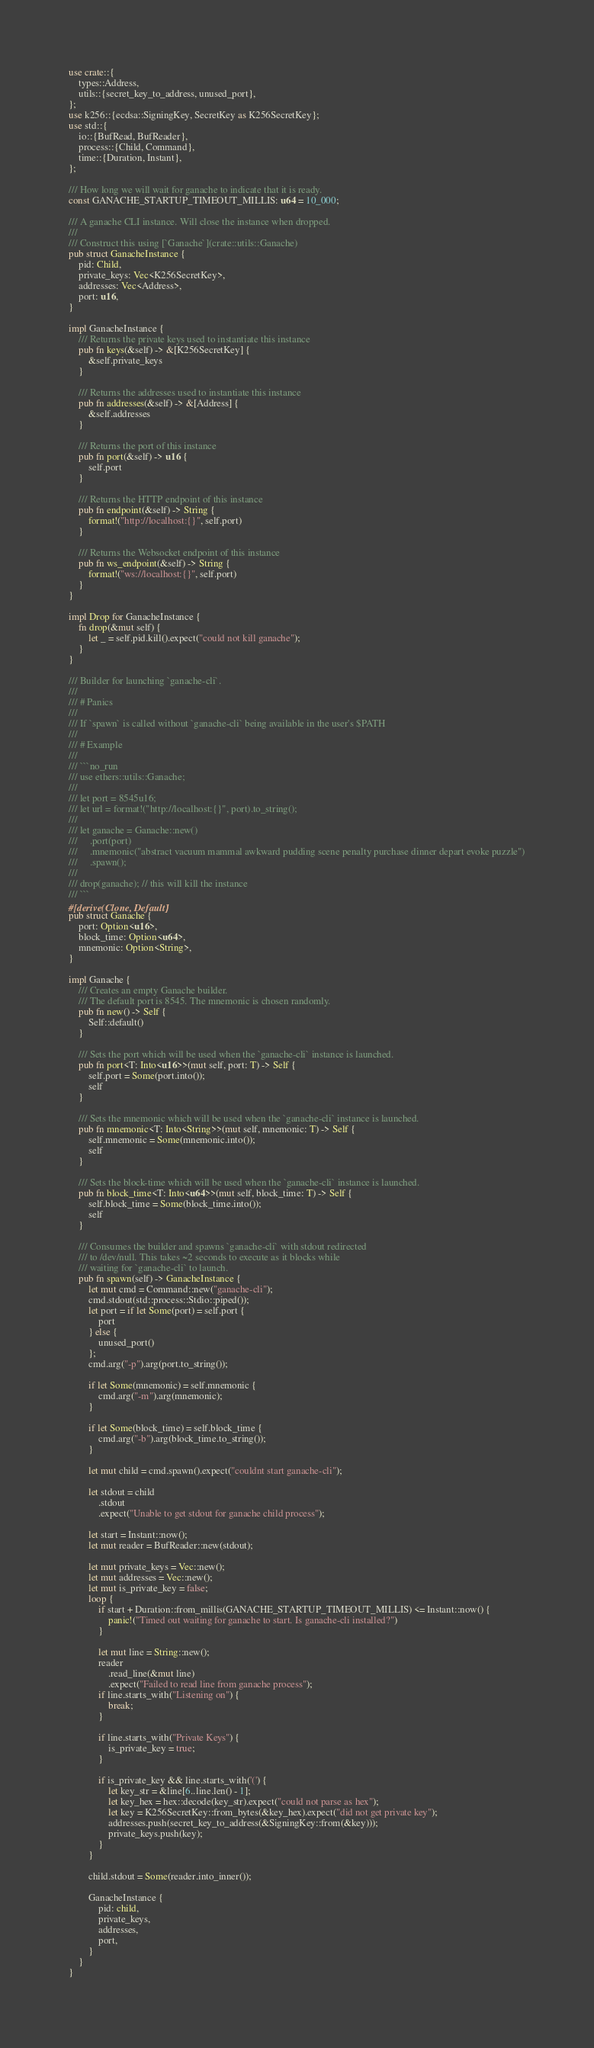Convert code to text. <code><loc_0><loc_0><loc_500><loc_500><_Rust_>use crate::{
    types::Address,
    utils::{secret_key_to_address, unused_port},
};
use k256::{ecdsa::SigningKey, SecretKey as K256SecretKey};
use std::{
    io::{BufRead, BufReader},
    process::{Child, Command},
    time::{Duration, Instant},
};

/// How long we will wait for ganache to indicate that it is ready.
const GANACHE_STARTUP_TIMEOUT_MILLIS: u64 = 10_000;

/// A ganache CLI instance. Will close the instance when dropped.
///
/// Construct this using [`Ganache`](crate::utils::Ganache)
pub struct GanacheInstance {
    pid: Child,
    private_keys: Vec<K256SecretKey>,
    addresses: Vec<Address>,
    port: u16,
}

impl GanacheInstance {
    /// Returns the private keys used to instantiate this instance
    pub fn keys(&self) -> &[K256SecretKey] {
        &self.private_keys
    }

    /// Returns the addresses used to instantiate this instance
    pub fn addresses(&self) -> &[Address] {
        &self.addresses
    }

    /// Returns the port of this instance
    pub fn port(&self) -> u16 {
        self.port
    }

    /// Returns the HTTP endpoint of this instance
    pub fn endpoint(&self) -> String {
        format!("http://localhost:{}", self.port)
    }

    /// Returns the Websocket endpoint of this instance
    pub fn ws_endpoint(&self) -> String {
        format!("ws://localhost:{}", self.port)
    }
}

impl Drop for GanacheInstance {
    fn drop(&mut self) {
        let _ = self.pid.kill().expect("could not kill ganache");
    }
}

/// Builder for launching `ganache-cli`.
///
/// # Panics
///
/// If `spawn` is called without `ganache-cli` being available in the user's $PATH
///
/// # Example
///
/// ```no_run
/// use ethers::utils::Ganache;
///
/// let port = 8545u16;
/// let url = format!("http://localhost:{}", port).to_string();
///
/// let ganache = Ganache::new()
///     .port(port)
///     .mnemonic("abstract vacuum mammal awkward pudding scene penalty purchase dinner depart evoke puzzle")
///     .spawn();
///
/// drop(ganache); // this will kill the instance
/// ```
#[derive(Clone, Default)]
pub struct Ganache {
    port: Option<u16>,
    block_time: Option<u64>,
    mnemonic: Option<String>,
}

impl Ganache {
    /// Creates an empty Ganache builder.
    /// The default port is 8545. The mnemonic is chosen randomly.
    pub fn new() -> Self {
        Self::default()
    }

    /// Sets the port which will be used when the `ganache-cli` instance is launched.
    pub fn port<T: Into<u16>>(mut self, port: T) -> Self {
        self.port = Some(port.into());
        self
    }

    /// Sets the mnemonic which will be used when the `ganache-cli` instance is launched.
    pub fn mnemonic<T: Into<String>>(mut self, mnemonic: T) -> Self {
        self.mnemonic = Some(mnemonic.into());
        self
    }

    /// Sets the block-time which will be used when the `ganache-cli` instance is launched.
    pub fn block_time<T: Into<u64>>(mut self, block_time: T) -> Self {
        self.block_time = Some(block_time.into());
        self
    }

    /// Consumes the builder and spawns `ganache-cli` with stdout redirected
    /// to /dev/null. This takes ~2 seconds to execute as it blocks while
    /// waiting for `ganache-cli` to launch.
    pub fn spawn(self) -> GanacheInstance {
        let mut cmd = Command::new("ganache-cli");
        cmd.stdout(std::process::Stdio::piped());
        let port = if let Some(port) = self.port {
            port
        } else {
            unused_port()
        };
        cmd.arg("-p").arg(port.to_string());

        if let Some(mnemonic) = self.mnemonic {
            cmd.arg("-m").arg(mnemonic);
        }

        if let Some(block_time) = self.block_time {
            cmd.arg("-b").arg(block_time.to_string());
        }

        let mut child = cmd.spawn().expect("couldnt start ganache-cli");

        let stdout = child
            .stdout
            .expect("Unable to get stdout for ganache child process");

        let start = Instant::now();
        let mut reader = BufReader::new(stdout);

        let mut private_keys = Vec::new();
        let mut addresses = Vec::new();
        let mut is_private_key = false;
        loop {
            if start + Duration::from_millis(GANACHE_STARTUP_TIMEOUT_MILLIS) <= Instant::now() {
                panic!("Timed out waiting for ganache to start. Is ganache-cli installed?")
            }

            let mut line = String::new();
            reader
                .read_line(&mut line)
                .expect("Failed to read line from ganache process");
            if line.starts_with("Listening on") {
                break;
            }

            if line.starts_with("Private Keys") {
                is_private_key = true;
            }

            if is_private_key && line.starts_with('(') {
                let key_str = &line[6..line.len() - 1];
                let key_hex = hex::decode(key_str).expect("could not parse as hex");
                let key = K256SecretKey::from_bytes(&key_hex).expect("did not get private key");
                addresses.push(secret_key_to_address(&SigningKey::from(&key)));
                private_keys.push(key);
            }
        }

        child.stdout = Some(reader.into_inner());

        GanacheInstance {
            pid: child,
            private_keys,
            addresses,
            port,
        }
    }
}
</code> 